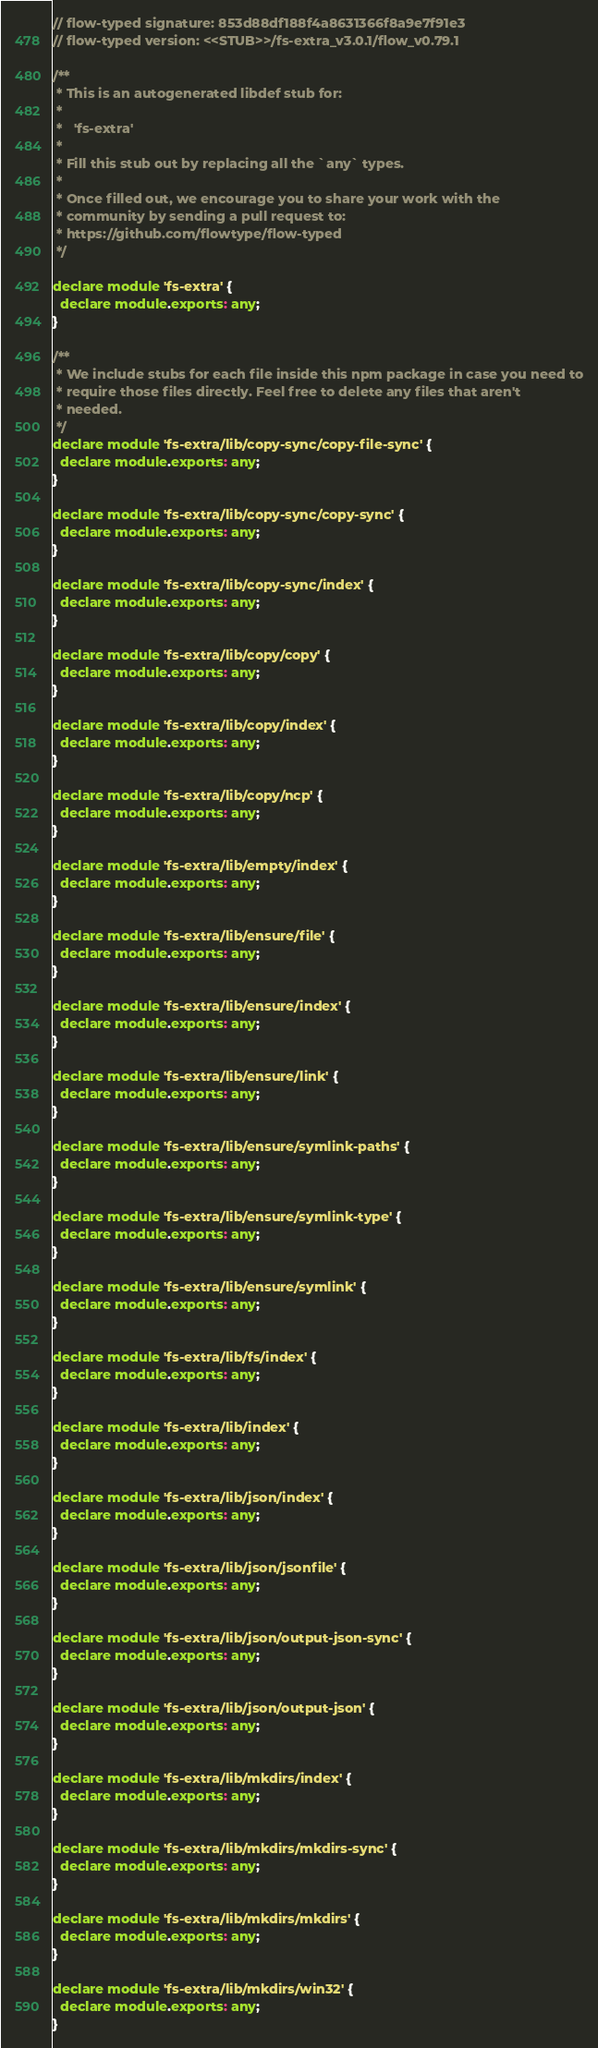Convert code to text. <code><loc_0><loc_0><loc_500><loc_500><_JavaScript_>// flow-typed signature: 853d88df188f4a8631366f8a9e7f91e3
// flow-typed version: <<STUB>>/fs-extra_v3.0.1/flow_v0.79.1

/**
 * This is an autogenerated libdef stub for:
 *
 *   'fs-extra'
 *
 * Fill this stub out by replacing all the `any` types.
 *
 * Once filled out, we encourage you to share your work with the
 * community by sending a pull request to:
 * https://github.com/flowtype/flow-typed
 */

declare module 'fs-extra' {
  declare module.exports: any;
}

/**
 * We include stubs for each file inside this npm package in case you need to
 * require those files directly. Feel free to delete any files that aren't
 * needed.
 */
declare module 'fs-extra/lib/copy-sync/copy-file-sync' {
  declare module.exports: any;
}

declare module 'fs-extra/lib/copy-sync/copy-sync' {
  declare module.exports: any;
}

declare module 'fs-extra/lib/copy-sync/index' {
  declare module.exports: any;
}

declare module 'fs-extra/lib/copy/copy' {
  declare module.exports: any;
}

declare module 'fs-extra/lib/copy/index' {
  declare module.exports: any;
}

declare module 'fs-extra/lib/copy/ncp' {
  declare module.exports: any;
}

declare module 'fs-extra/lib/empty/index' {
  declare module.exports: any;
}

declare module 'fs-extra/lib/ensure/file' {
  declare module.exports: any;
}

declare module 'fs-extra/lib/ensure/index' {
  declare module.exports: any;
}

declare module 'fs-extra/lib/ensure/link' {
  declare module.exports: any;
}

declare module 'fs-extra/lib/ensure/symlink-paths' {
  declare module.exports: any;
}

declare module 'fs-extra/lib/ensure/symlink-type' {
  declare module.exports: any;
}

declare module 'fs-extra/lib/ensure/symlink' {
  declare module.exports: any;
}

declare module 'fs-extra/lib/fs/index' {
  declare module.exports: any;
}

declare module 'fs-extra/lib/index' {
  declare module.exports: any;
}

declare module 'fs-extra/lib/json/index' {
  declare module.exports: any;
}

declare module 'fs-extra/lib/json/jsonfile' {
  declare module.exports: any;
}

declare module 'fs-extra/lib/json/output-json-sync' {
  declare module.exports: any;
}

declare module 'fs-extra/lib/json/output-json' {
  declare module.exports: any;
}

declare module 'fs-extra/lib/mkdirs/index' {
  declare module.exports: any;
}

declare module 'fs-extra/lib/mkdirs/mkdirs-sync' {
  declare module.exports: any;
}

declare module 'fs-extra/lib/mkdirs/mkdirs' {
  declare module.exports: any;
}

declare module 'fs-extra/lib/mkdirs/win32' {
  declare module.exports: any;
}
</code> 